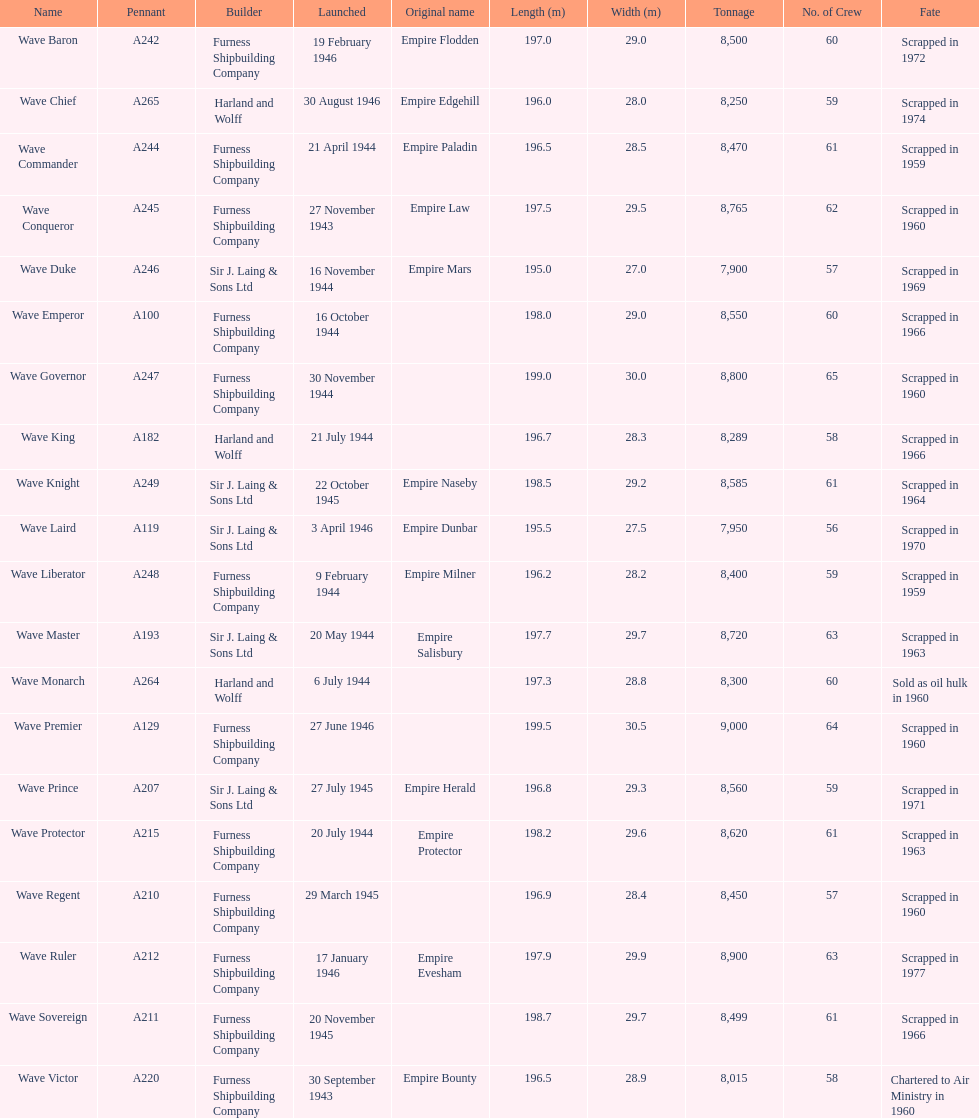What other boat was launched during the same year as the wave victor? Wave Conqueror. 